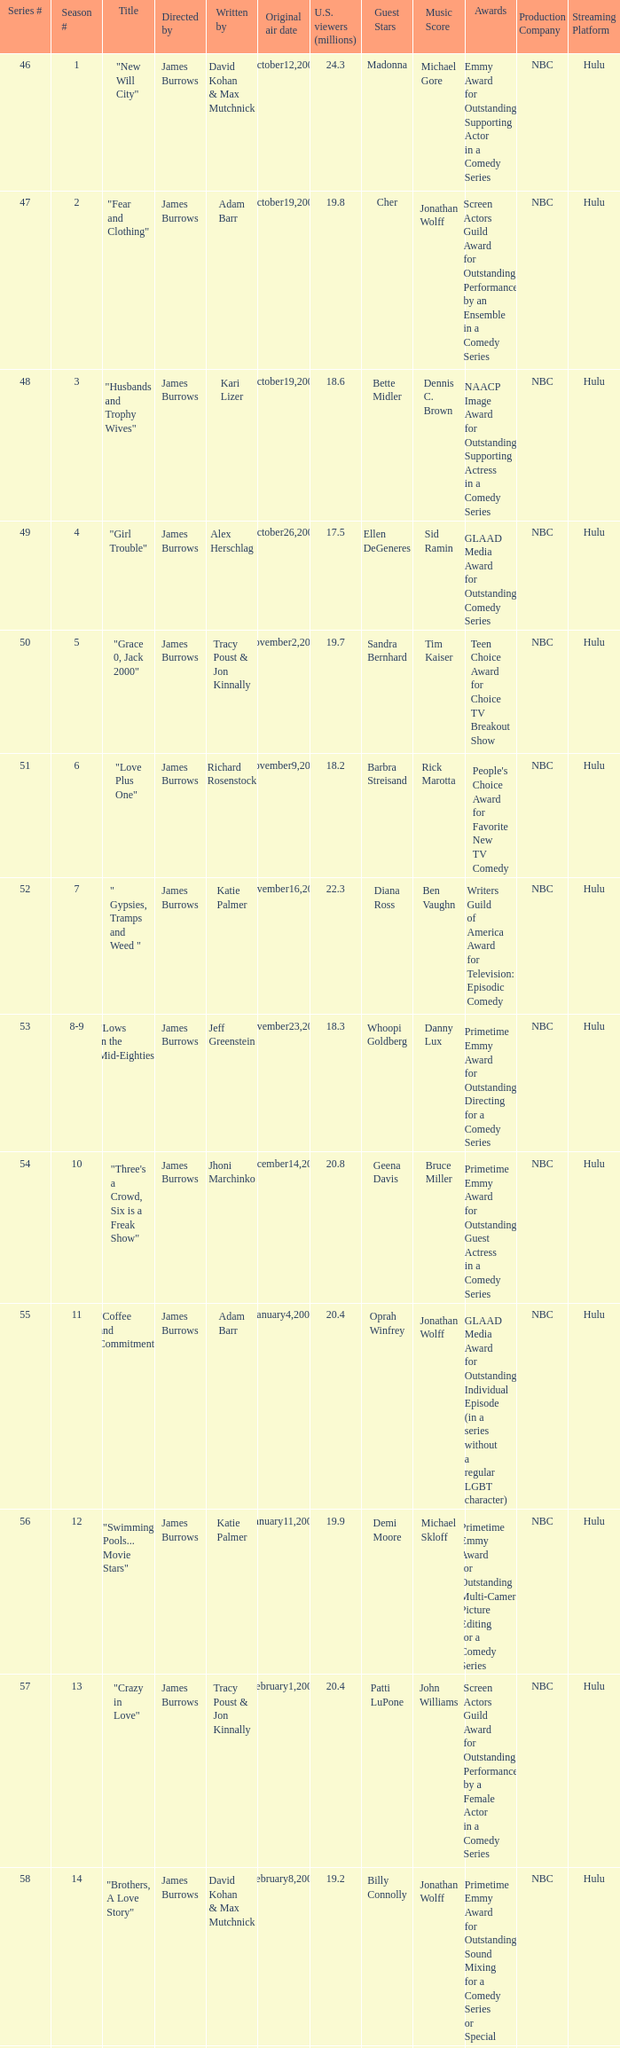Who wrote the episode titled "An Old-fashioned Piano Party"? Jhoni Marchinko, Tracy Poust & Jon Kinnally. 